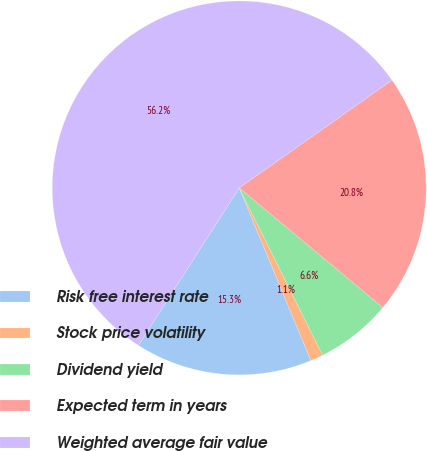<chart> <loc_0><loc_0><loc_500><loc_500><pie_chart><fcel>Risk free interest rate<fcel>Stock price volatility<fcel>Dividend yield<fcel>Expected term in years<fcel>Weighted average fair value<nl><fcel>15.32%<fcel>1.09%<fcel>6.6%<fcel>20.83%<fcel>56.16%<nl></chart> 